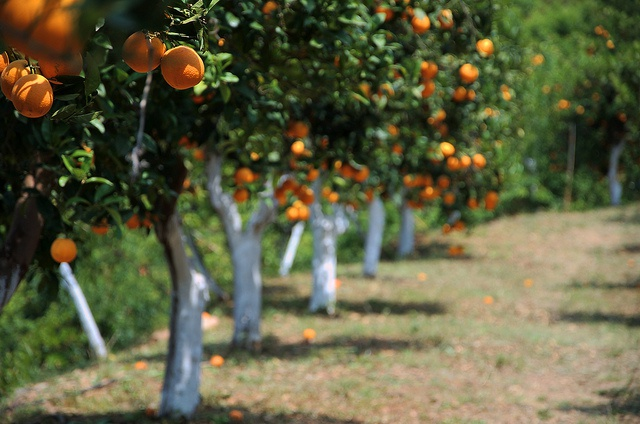Describe the objects in this image and their specific colors. I can see orange in black, brown, maroon, and olive tones, orange in black, maroon, brown, and orange tones, orange in black, maroon, and brown tones, orange in black, maroon, brown, and red tones, and orange in black, maroon, brown, and orange tones in this image. 